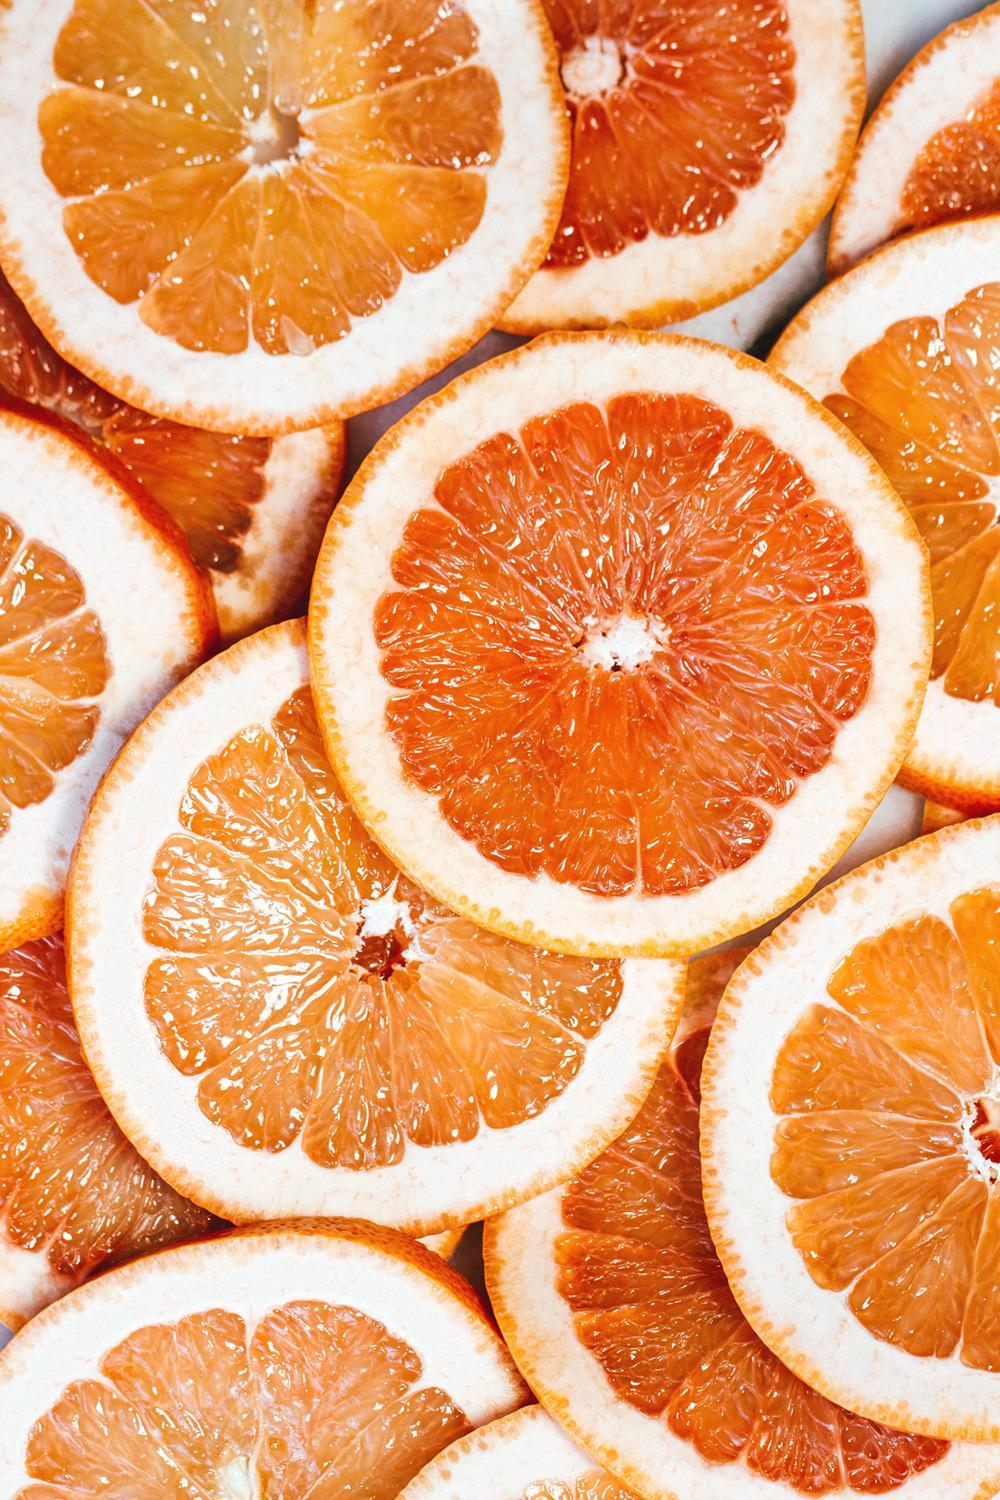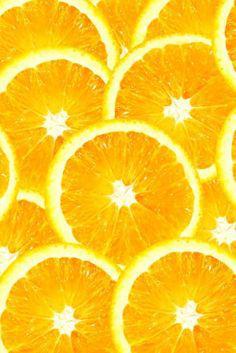The first image is the image on the left, the second image is the image on the right. Considering the images on both sides, is "In one image, the oranges are quartered and in the other they are sliced circles." valid? Answer yes or no. No. 